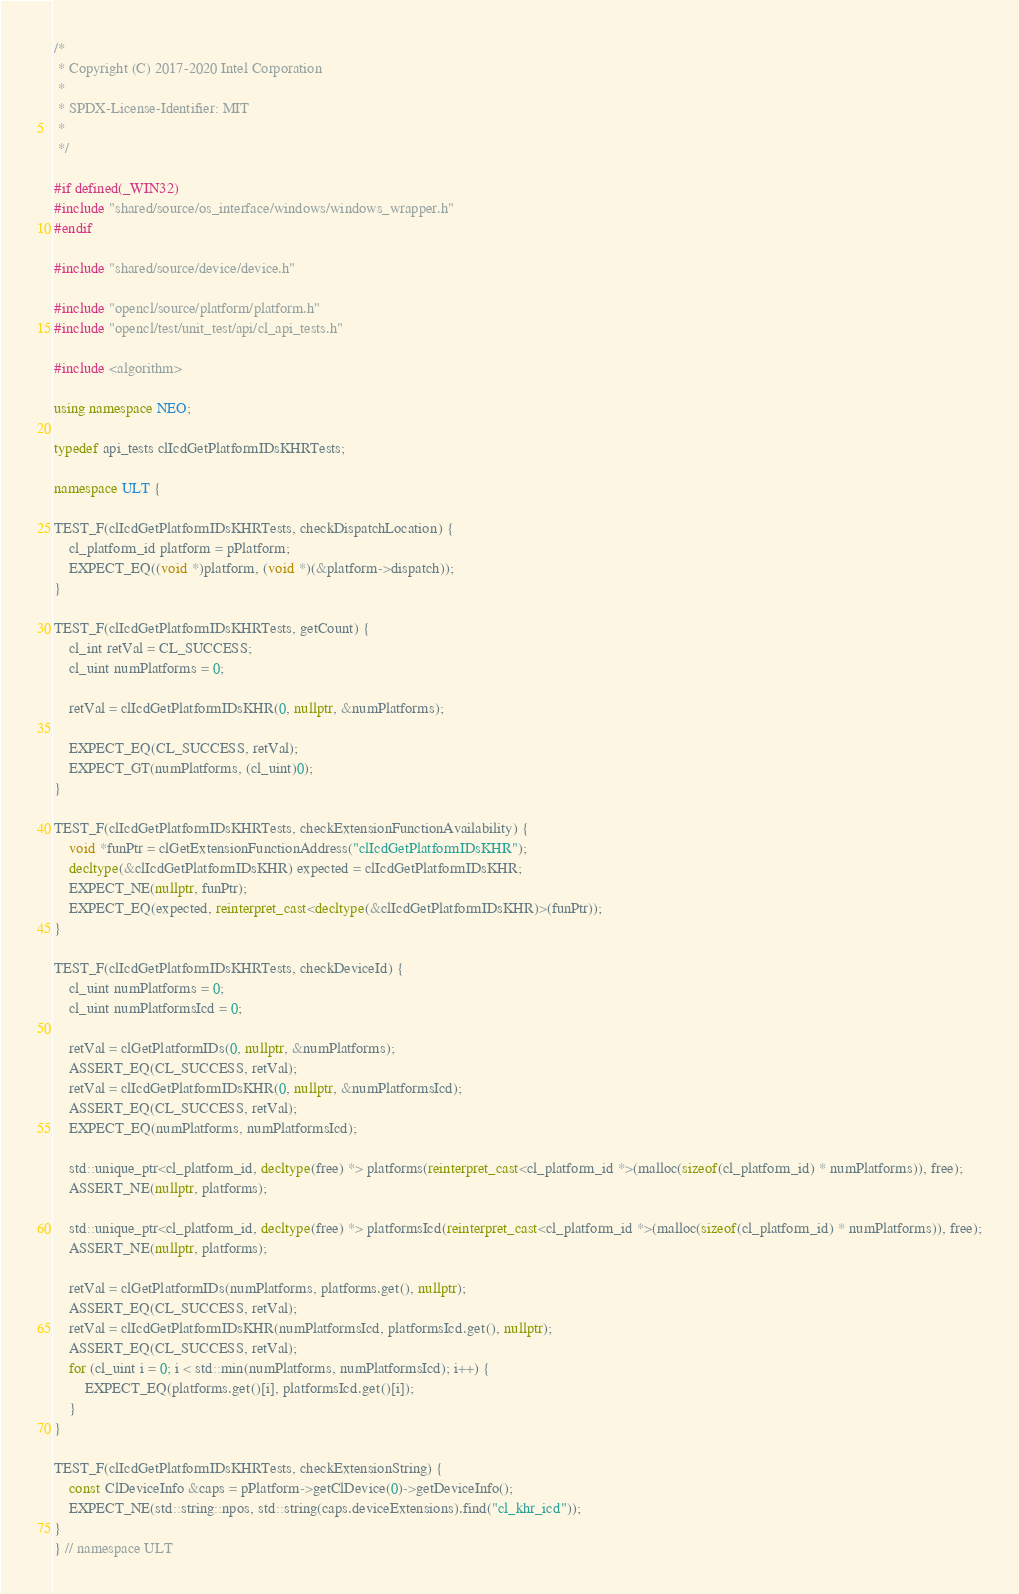Convert code to text. <code><loc_0><loc_0><loc_500><loc_500><_C++_>/*
 * Copyright (C) 2017-2020 Intel Corporation
 *
 * SPDX-License-Identifier: MIT
 *
 */

#if defined(_WIN32)
#include "shared/source/os_interface/windows/windows_wrapper.h"
#endif

#include "shared/source/device/device.h"

#include "opencl/source/platform/platform.h"
#include "opencl/test/unit_test/api/cl_api_tests.h"

#include <algorithm>

using namespace NEO;

typedef api_tests clIcdGetPlatformIDsKHRTests;

namespace ULT {

TEST_F(clIcdGetPlatformIDsKHRTests, checkDispatchLocation) {
    cl_platform_id platform = pPlatform;
    EXPECT_EQ((void *)platform, (void *)(&platform->dispatch));
}

TEST_F(clIcdGetPlatformIDsKHRTests, getCount) {
    cl_int retVal = CL_SUCCESS;
    cl_uint numPlatforms = 0;

    retVal = clIcdGetPlatformIDsKHR(0, nullptr, &numPlatforms);

    EXPECT_EQ(CL_SUCCESS, retVal);
    EXPECT_GT(numPlatforms, (cl_uint)0);
}

TEST_F(clIcdGetPlatformIDsKHRTests, checkExtensionFunctionAvailability) {
    void *funPtr = clGetExtensionFunctionAddress("clIcdGetPlatformIDsKHR");
    decltype(&clIcdGetPlatformIDsKHR) expected = clIcdGetPlatformIDsKHR;
    EXPECT_NE(nullptr, funPtr);
    EXPECT_EQ(expected, reinterpret_cast<decltype(&clIcdGetPlatformIDsKHR)>(funPtr));
}

TEST_F(clIcdGetPlatformIDsKHRTests, checkDeviceId) {
    cl_uint numPlatforms = 0;
    cl_uint numPlatformsIcd = 0;

    retVal = clGetPlatformIDs(0, nullptr, &numPlatforms);
    ASSERT_EQ(CL_SUCCESS, retVal);
    retVal = clIcdGetPlatformIDsKHR(0, nullptr, &numPlatformsIcd);
    ASSERT_EQ(CL_SUCCESS, retVal);
    EXPECT_EQ(numPlatforms, numPlatformsIcd);

    std::unique_ptr<cl_platform_id, decltype(free) *> platforms(reinterpret_cast<cl_platform_id *>(malloc(sizeof(cl_platform_id) * numPlatforms)), free);
    ASSERT_NE(nullptr, platforms);

    std::unique_ptr<cl_platform_id, decltype(free) *> platformsIcd(reinterpret_cast<cl_platform_id *>(malloc(sizeof(cl_platform_id) * numPlatforms)), free);
    ASSERT_NE(nullptr, platforms);

    retVal = clGetPlatformIDs(numPlatforms, platforms.get(), nullptr);
    ASSERT_EQ(CL_SUCCESS, retVal);
    retVal = clIcdGetPlatformIDsKHR(numPlatformsIcd, platformsIcd.get(), nullptr);
    ASSERT_EQ(CL_SUCCESS, retVal);
    for (cl_uint i = 0; i < std::min(numPlatforms, numPlatformsIcd); i++) {
        EXPECT_EQ(platforms.get()[i], platformsIcd.get()[i]);
    }
}

TEST_F(clIcdGetPlatformIDsKHRTests, checkExtensionString) {
    const ClDeviceInfo &caps = pPlatform->getClDevice(0)->getDeviceInfo();
    EXPECT_NE(std::string::npos, std::string(caps.deviceExtensions).find("cl_khr_icd"));
}
} // namespace ULT
</code> 